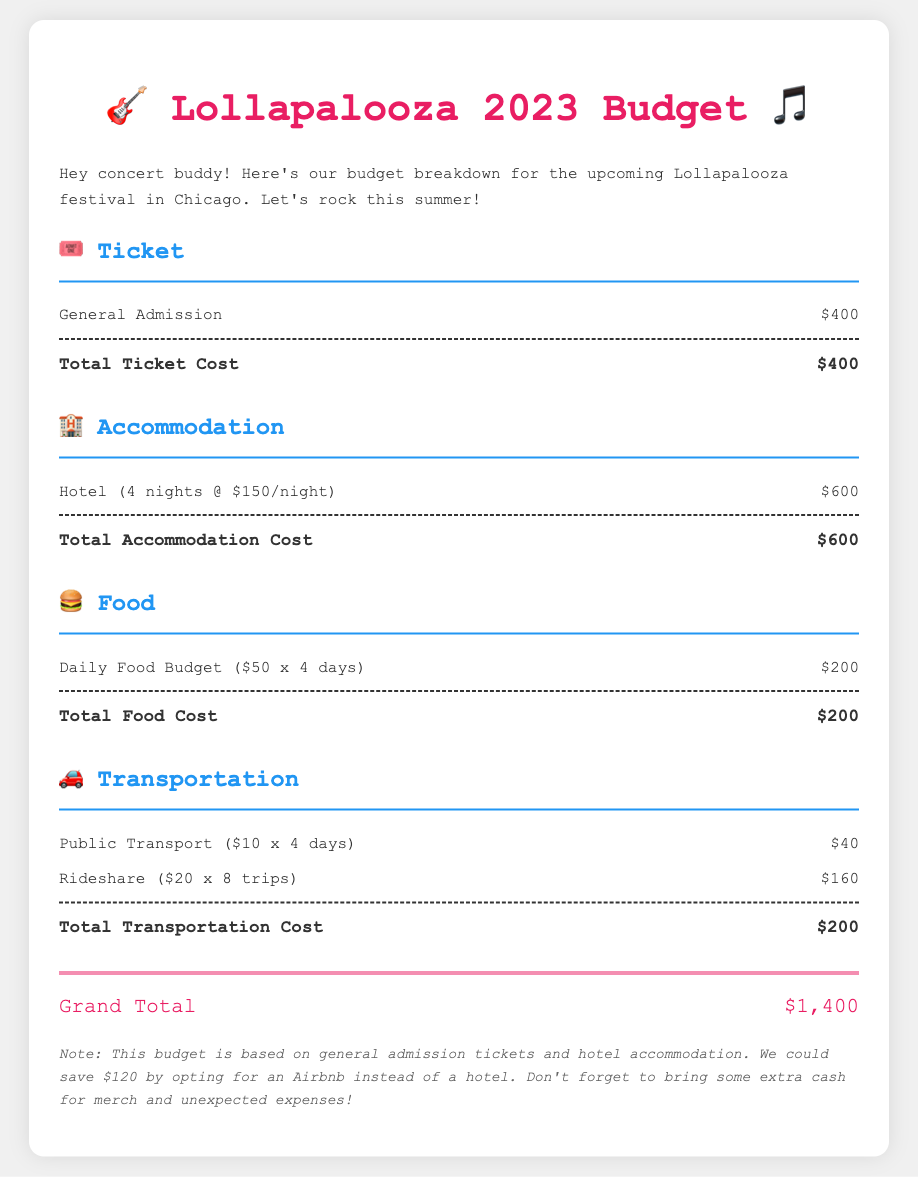What is the total ticket cost? The total ticket cost is listed under the ticket category, which is $400.
Answer: $400 How much does accommodation cost for 4 nights? The accommodation cost for 4 nights at $150 per night totals to $600.
Answer: $600 What is the daily food budget amount? The daily food budget is stated as $50 per day, which is part of the food expenses.
Answer: $50 What is the total transportation cost? The total transportation cost is the sum of public transport and rideshare expenses, which is $200.
Answer: $200 How much can we save by opting for an Airbnb? The note mentions that we could save $120 by choosing an Airbnb instead of a hotel.
Answer: $120 What is the grand total of the budget? The grand total is calculated and shown at the bottom as $1,400.
Answer: $1,400 How many days is the festival budgeted for? The festival budget is planned for a total of 4 days, as indicated in the food and transport calculations.
Answer: 4 days What are the total food expenses for the trip? The total food expenses are based on the daily food budget for 4 days and amount to $200.
Answer: $200 